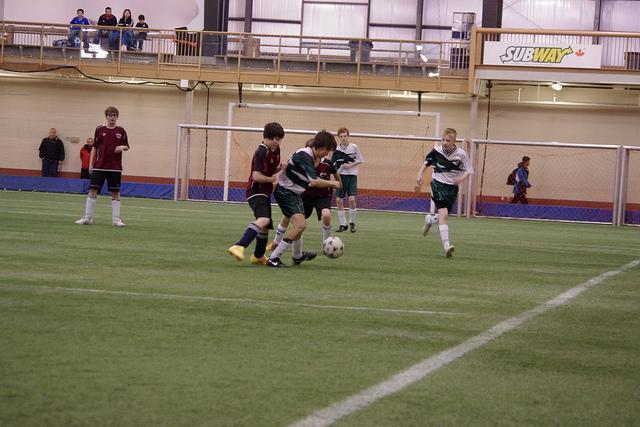How many people can be seen?
Give a very brief answer. 4. How many real dogs are there?
Give a very brief answer. 0. 